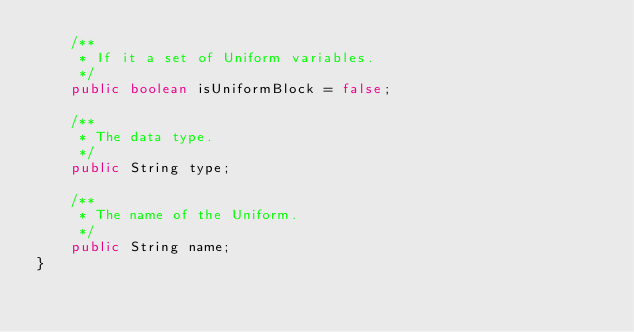Convert code to text. <code><loc_0><loc_0><loc_500><loc_500><_Java_>    /**
     * If it a set of Uniform variables.
     */
    public boolean isUniformBlock = false;

    /**
     * The data type.
     */
    public String type;

    /**
     * The name of the Uniform.
     */
    public String name;
}
</code> 